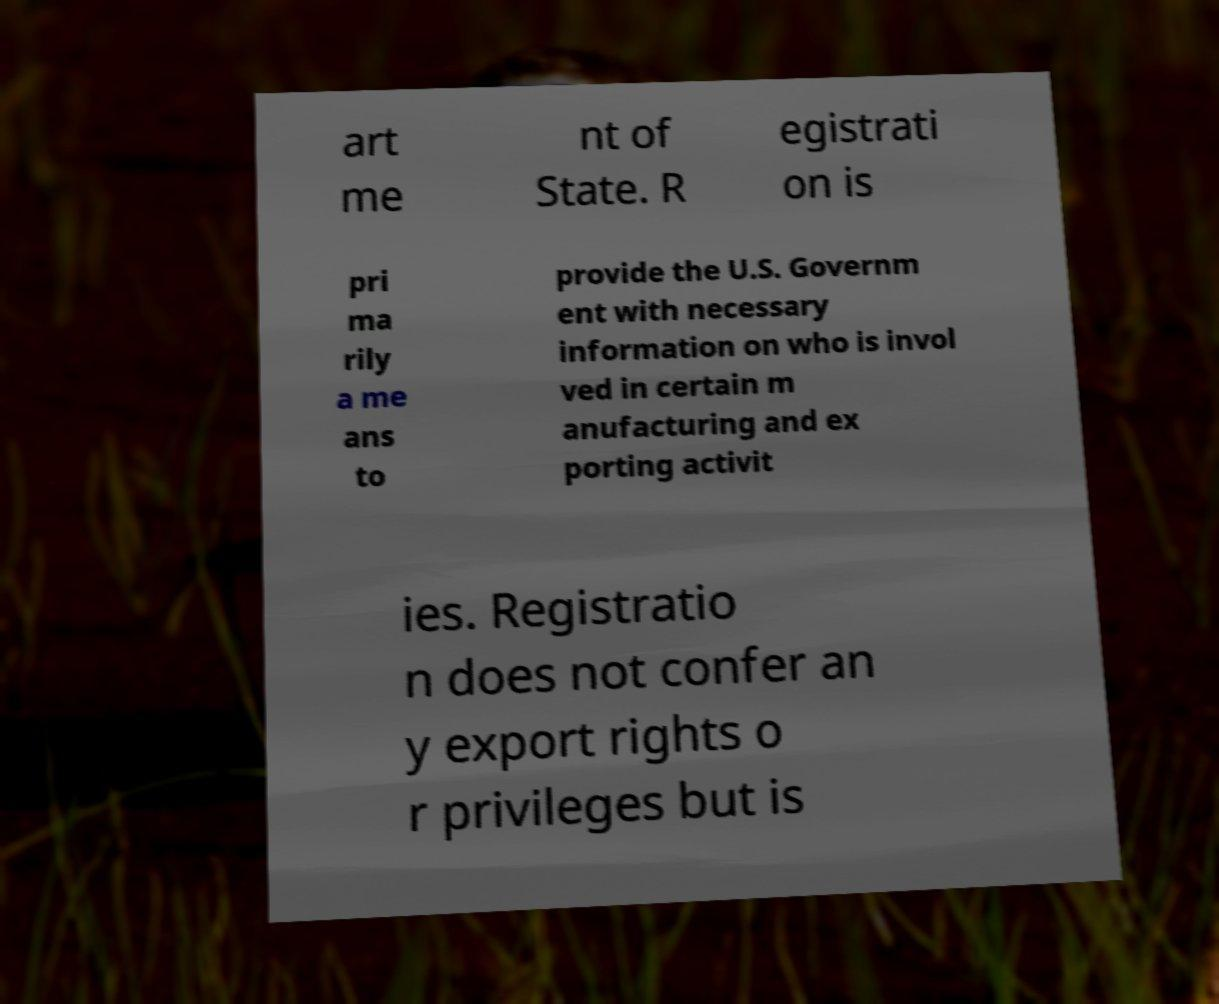Could you extract and type out the text from this image? art me nt of State. R egistrati on is pri ma rily a me ans to provide the U.S. Governm ent with necessary information on who is invol ved in certain m anufacturing and ex porting activit ies. Registratio n does not confer an y export rights o r privileges but is 